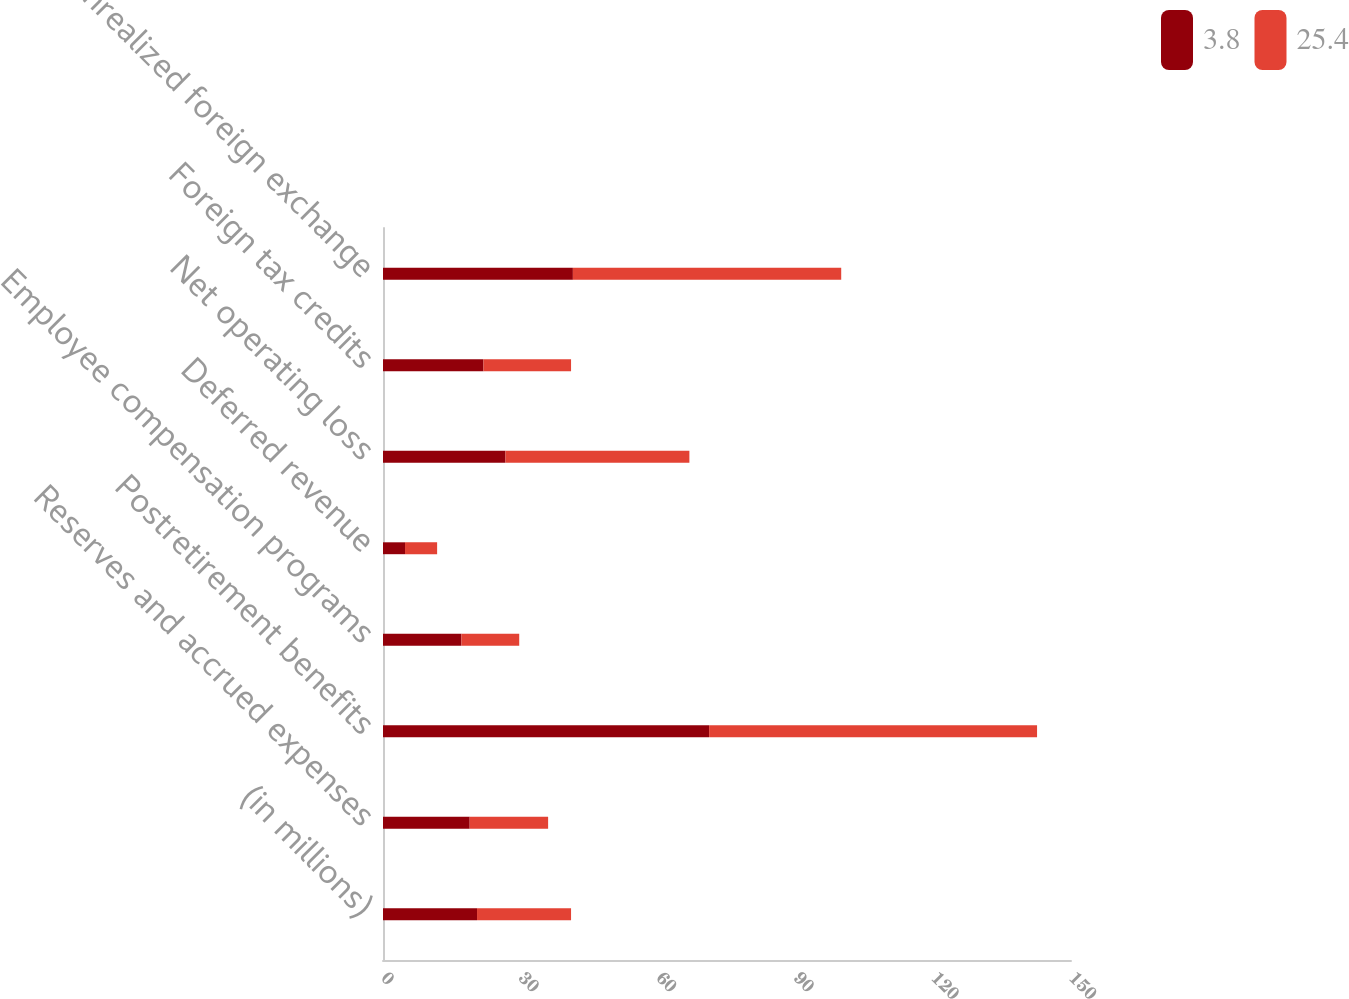Convert chart. <chart><loc_0><loc_0><loc_500><loc_500><stacked_bar_chart><ecel><fcel>(in millions)<fcel>Reserves and accrued expenses<fcel>Postretirement benefits<fcel>Employee compensation programs<fcel>Deferred revenue<fcel>Net operating loss<fcel>Foreign tax credits<fcel>Unrealized foreign exchange<nl><fcel>3.8<fcel>20.5<fcel>18.9<fcel>71.1<fcel>17.1<fcel>4.8<fcel>26.7<fcel>21.9<fcel>41.4<nl><fcel>25.4<fcel>20.5<fcel>17.1<fcel>71.5<fcel>12.6<fcel>7<fcel>40.1<fcel>19.1<fcel>58.5<nl></chart> 